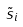<formula> <loc_0><loc_0><loc_500><loc_500>\tilde { s } _ { i }</formula> 